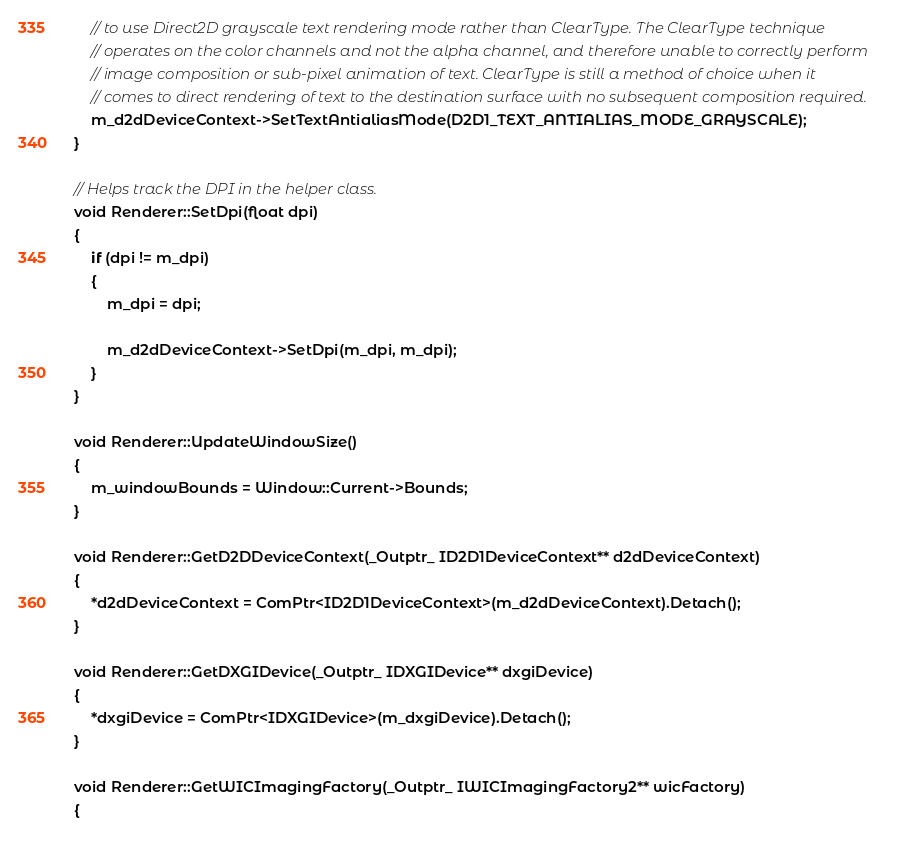<code> <loc_0><loc_0><loc_500><loc_500><_C++_>    // to use Direct2D grayscale text rendering mode rather than ClearType. The ClearType technique
    // operates on the color channels and not the alpha channel, and therefore unable to correctly perform
    // image composition or sub-pixel animation of text. ClearType is still a method of choice when it
    // comes to direct rendering of text to the destination surface with no subsequent composition required.
    m_d2dDeviceContext->SetTextAntialiasMode(D2D1_TEXT_ANTIALIAS_MODE_GRAYSCALE);
}

// Helps track the DPI in the helper class.
void Renderer::SetDpi(float dpi)
{
    if (dpi != m_dpi)
    {
        m_dpi = dpi;

        m_d2dDeviceContext->SetDpi(m_dpi, m_dpi);
    }
}

void Renderer::UpdateWindowSize()
{
    m_windowBounds = Window::Current->Bounds;
}

void Renderer::GetD2DDeviceContext(_Outptr_ ID2D1DeviceContext** d2dDeviceContext)
{
    *d2dDeviceContext = ComPtr<ID2D1DeviceContext>(m_d2dDeviceContext).Detach();
}

void Renderer::GetDXGIDevice(_Outptr_ IDXGIDevice** dxgiDevice)
{
    *dxgiDevice = ComPtr<IDXGIDevice>(m_dxgiDevice).Detach();
}

void Renderer::GetWICImagingFactory(_Outptr_ IWICImagingFactory2** wicFactory)
{</code> 